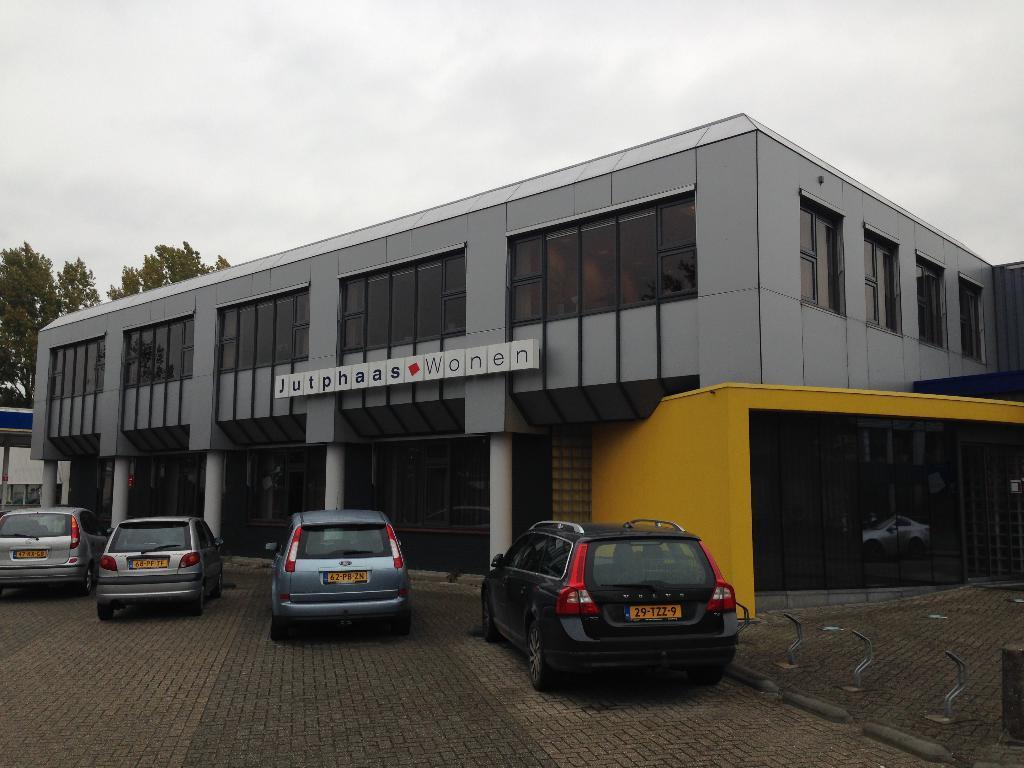How would you summarize this image in a sentence or two? In the image we can see there are four cars and the number plates. Here we can see footpath and the building. Here we can see text, trees and a cloudy sky. 